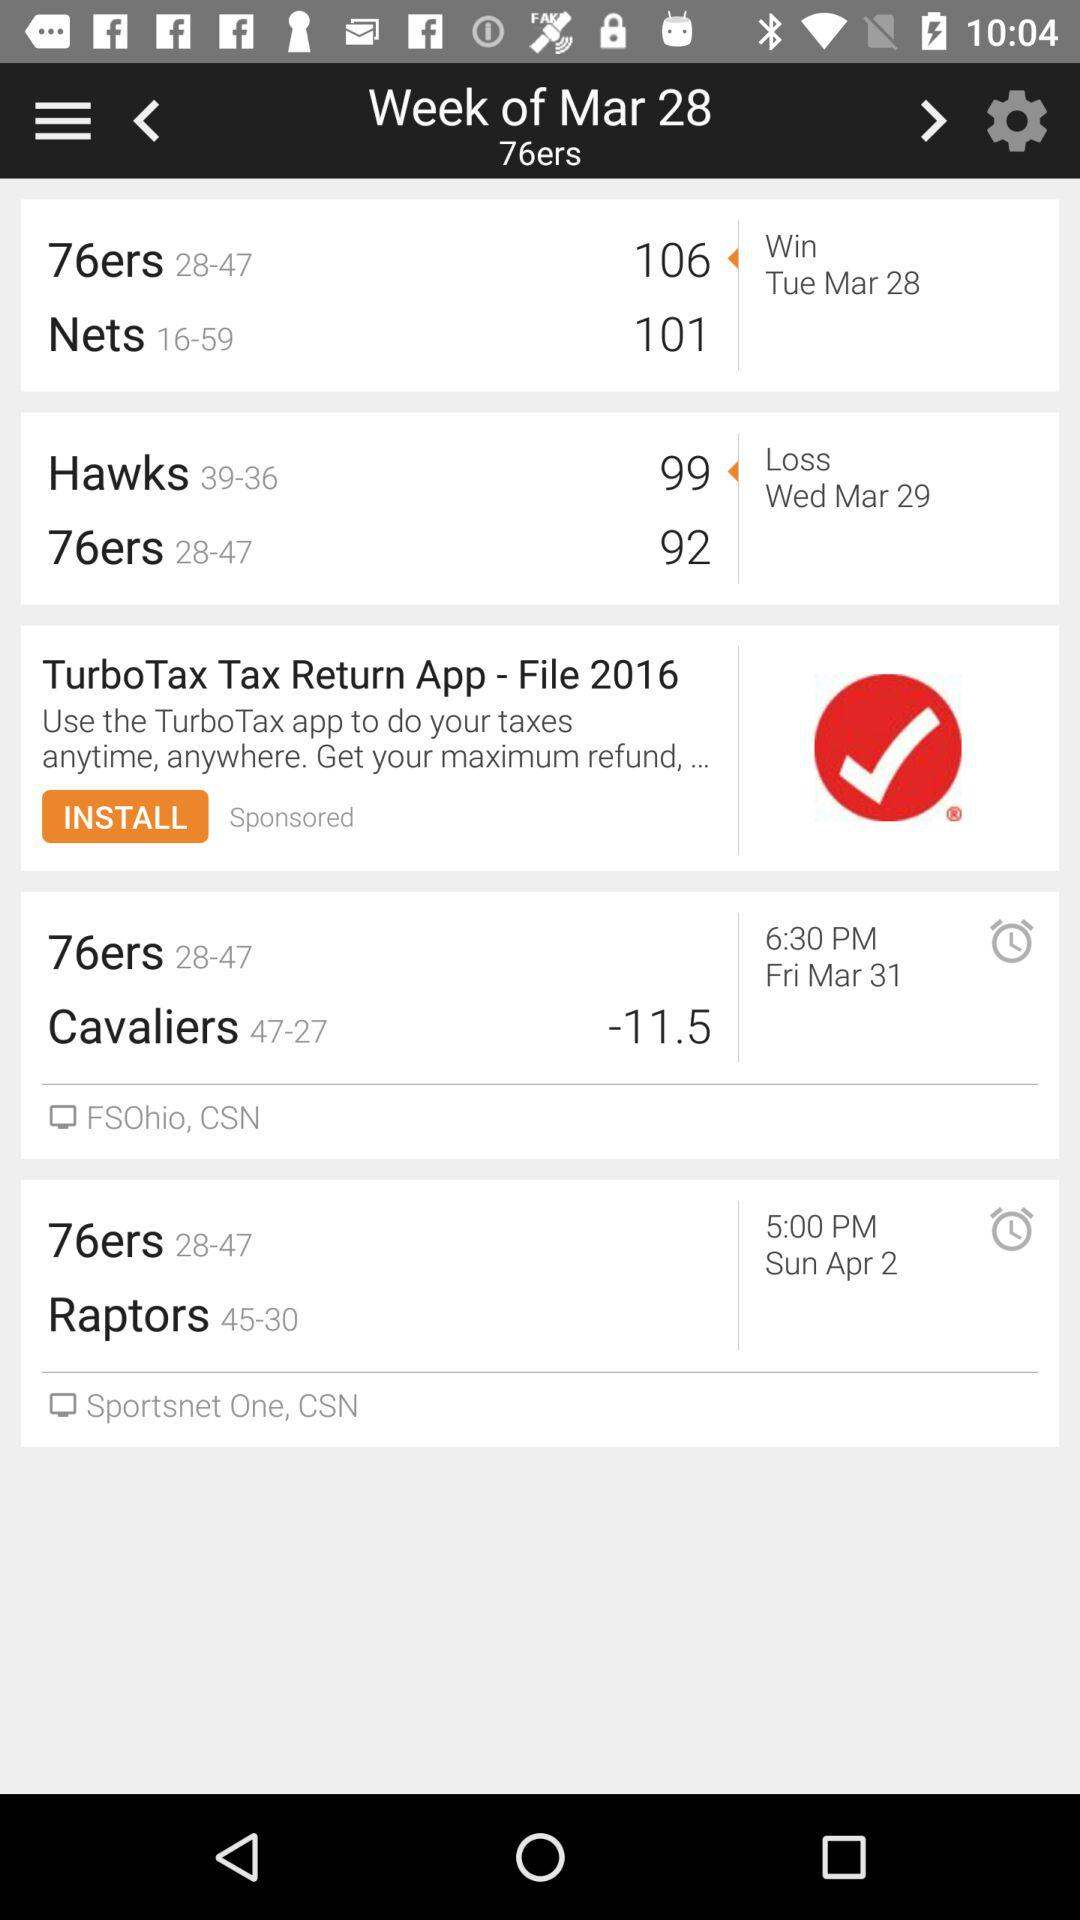What is the score of the "76ers" on March 28? The score is 106. 